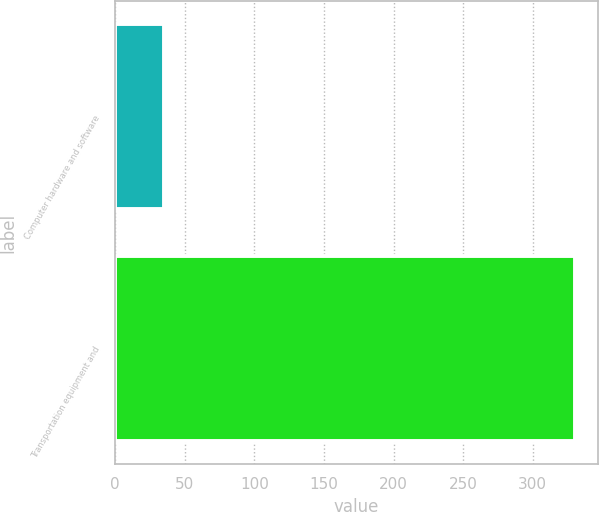<chart> <loc_0><loc_0><loc_500><loc_500><bar_chart><fcel>Computer hardware and software<fcel>Transportation equipment and<nl><fcel>35<fcel>330<nl></chart> 